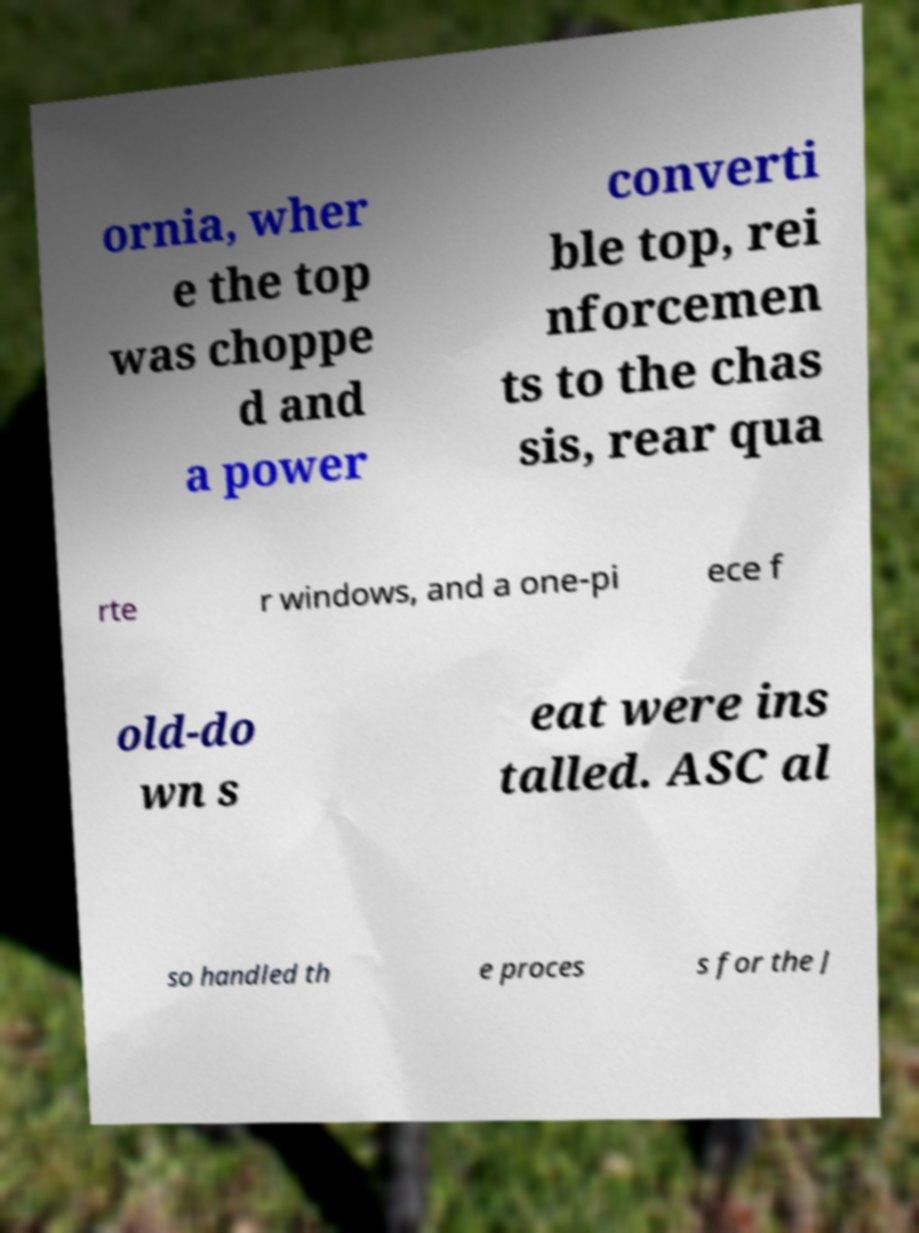Can you read and provide the text displayed in the image?This photo seems to have some interesting text. Can you extract and type it out for me? ornia, wher e the top was choppe d and a power converti ble top, rei nforcemen ts to the chas sis, rear qua rte r windows, and a one-pi ece f old-do wn s eat were ins talled. ASC al so handled th e proces s for the J 